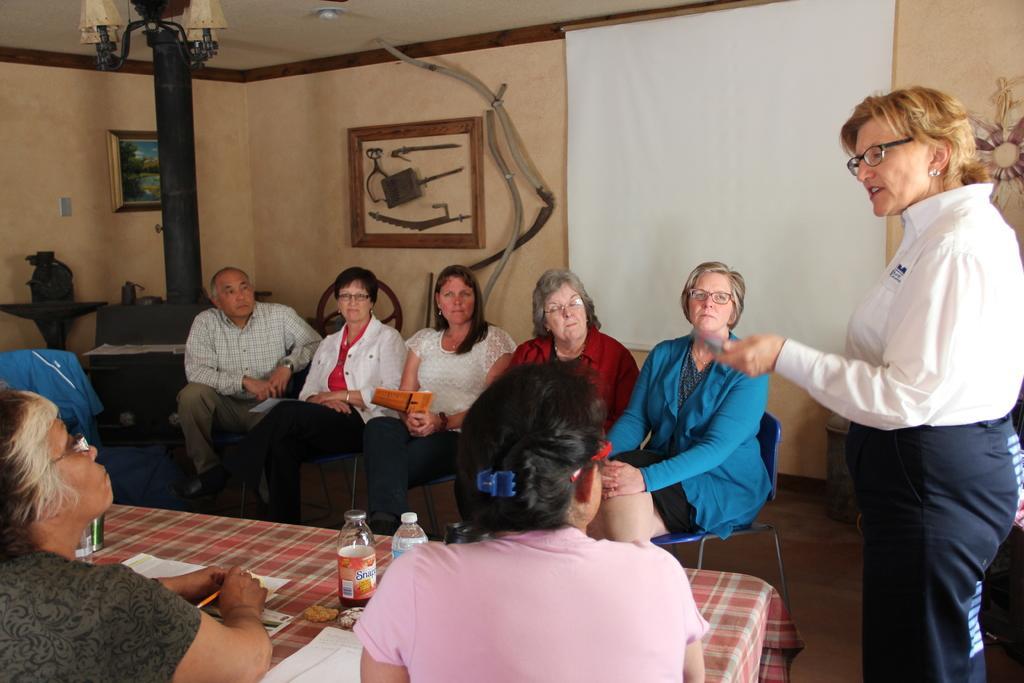Could you give a brief overview of what you see in this image? Here there are group of people siting on the chair, and in front there is the table there are bottles and some other objects on it, and a person standing on the floor, and here is the wall and and photo frame on it, and here is the lamp. 